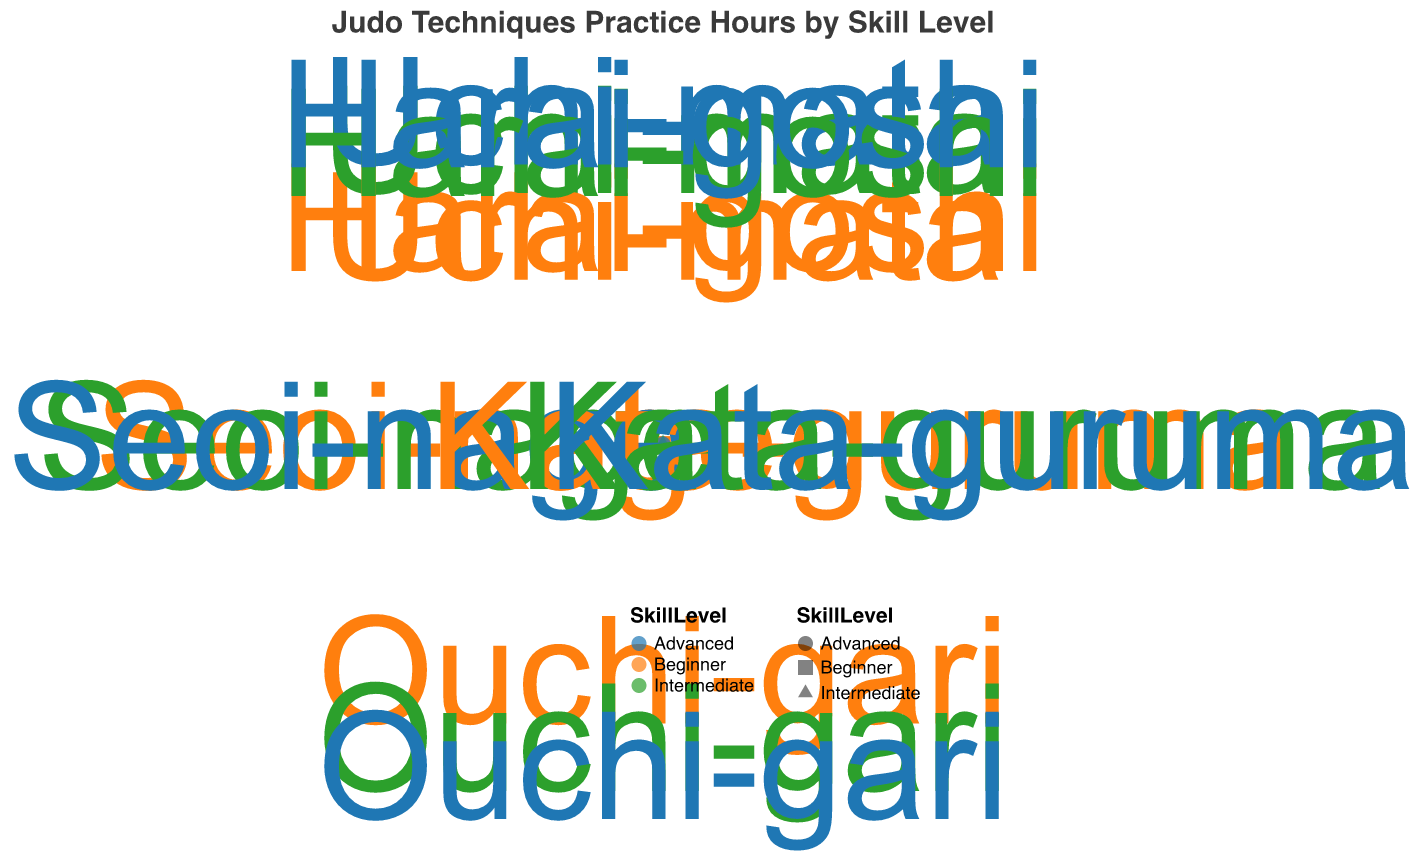What is the title of the chart? The title of the chart is usually placed at the top and is meant to provide a brief description of what the chart depicts. In this case, it reads "Judo Techniques Practice Hours by Skill Level".
Answer: Judo Techniques Practice Hours by Skill Level How many techniques are displayed on the chart? The techniques can be identified by the labels around the edge of the polar scatter chart. In this case, there are 5: Seoi-nage, Uchi-mata, Ouchi-gari, Kata-guruma, and Harai-goshi.
Answer: 5 Which skill level is represented by the circle shape? The chart uses different shapes to represent each skill level. By observing the legend or the plotted points, the circle shape represents the "Beginner" skill level.
Answer: Beginner Which technique had the highest number of hours of practice at the Advanced level? To find the technique with the highest hours, we look at the points farthest from the center among the Advanced skill levels. It is the point corresponding to Ouchi-gari with 280 hours.
Answer: Ouchi-gari How many hours did Beginners spend practicing Harai-goshi? Beginners' practice hours can be identified by the circle shape at the corresponding technique. For Harai-goshi, the circle is labeled with 110 hours.
Answer: 110 Which skill level spent the least amount of time practicing Kata-guruma? By examining the points closest to the center for Kata-guruma, the Beginner skill level (circle) represents the least amount of practice time with 90 hours.
Answer: Beginner What is the range of practice hours for the technique Uchi-mata across all skill levels? The range is calculated by finding the difference between the highest and lowest values for Uchi-mata. Advanced level has 270 hours and Beginner level has 100 hours, so the range is 270 - 100.
Answer: 170 Compare the practice hours of Seoi-nage and Uchi-mata at the Intermediate level. Which technique had more hours of practice? To compare, we look at the data points or labels for these techniques at the Intermediate level (square shape). Seoi-nage has 200 hours, and Uchi-mata has 220 hours.
Answer: Uchi-mata What is the average practice time for the technique Harai-goshi across all skill levels? To calculate the average, add up the practice hours for all skill levels for Harai-goshi and divide by the number of skill levels: (110 + 215 + 265) / 3 = 590 / 3.
Answer: 196.67 Identify and compare the hours spent by Advanced and Beginner levels practicing Uchi-mata. What is the difference in hours? Advanced level has 270 hours and Beginner level has 100 hours for Uchi-mata. The difference is 270 - 100.
Answer: 170 